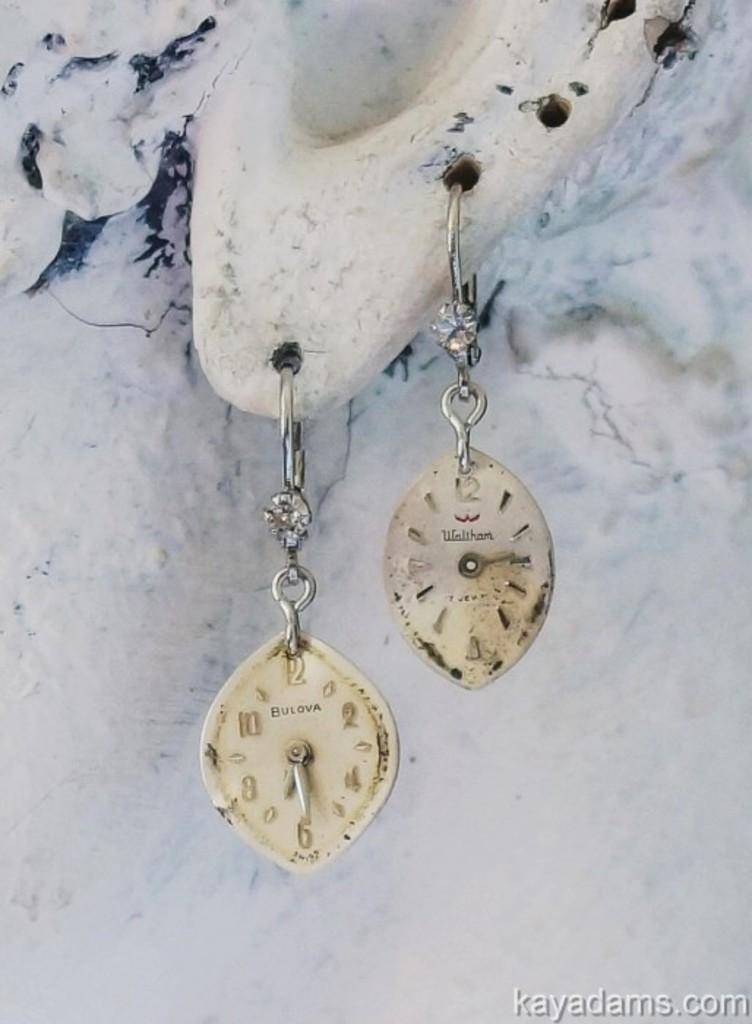What type of accessory is featured in the image? There are cream-colored earrings in the image. What color is the background of the image? The background of the image is white. What type of potato is shown resting on the earrings in the image? There is no potato present in the image, and the earrings are not resting on anything. 